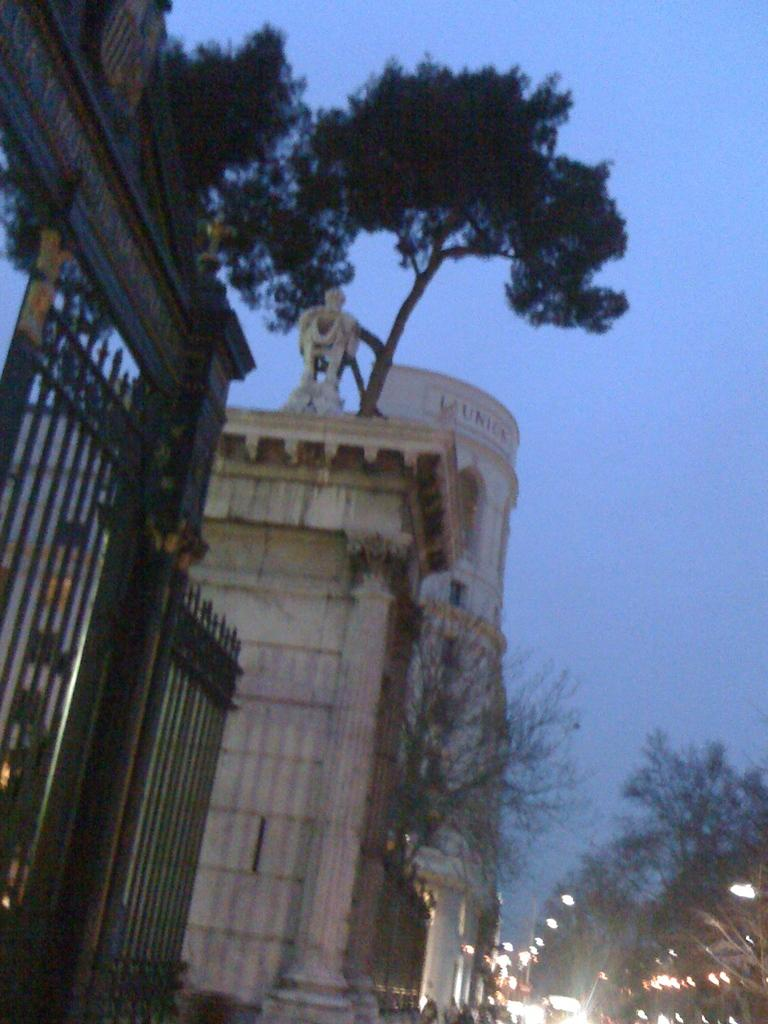What type of natural elements can be seen in the image? There are trees in the image. What type of man-made structures are present in the image? There are buildings in the image. Where are the lights located in the image? The lights are on the right side of the image. What is visible at the top of the image? The sky is visible at the top of the image. What is the condition of the sky in the image? The sky is clear in the image. How many chairs are visible in the image? There are no chairs present in the image. Is there any sleet falling from the clear sky in the image? There is no sleet present in the image, as the sky is clear. 